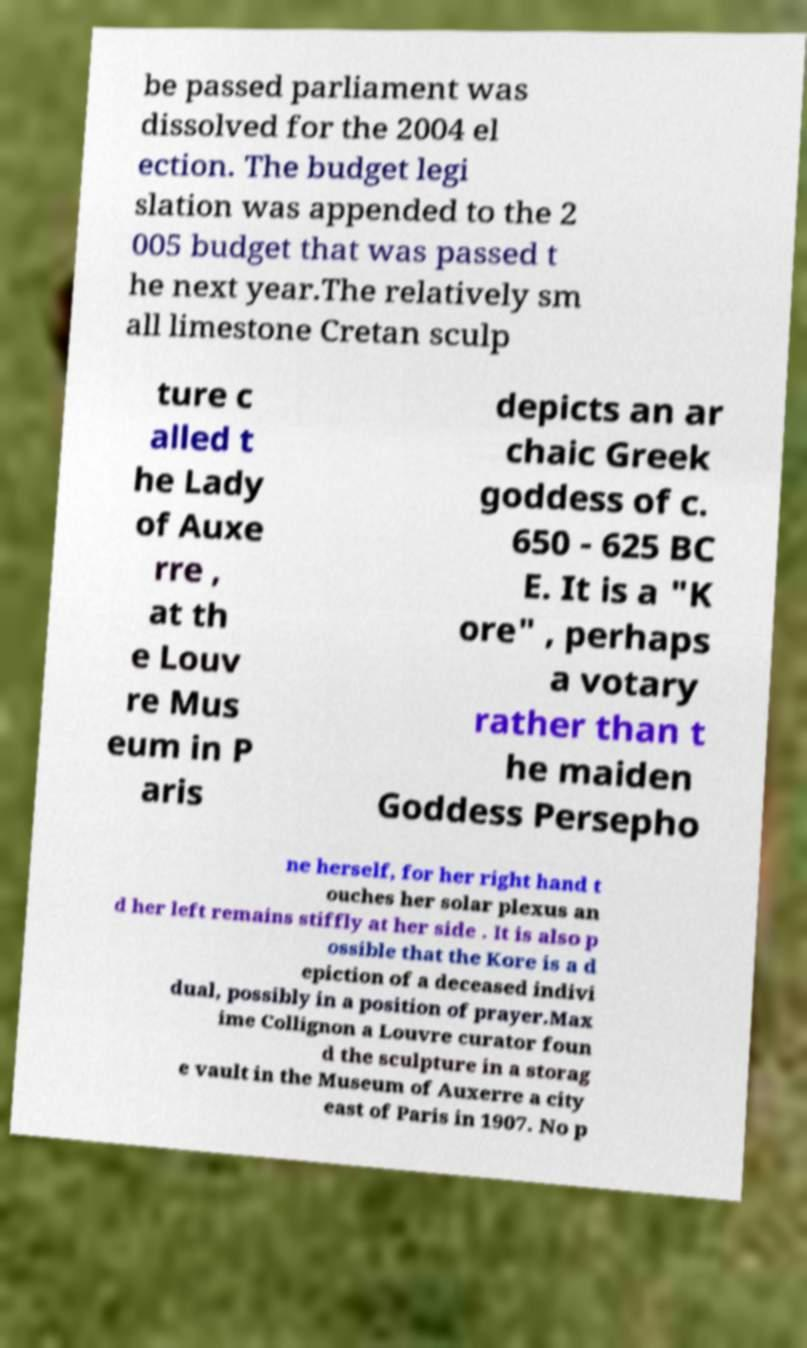Please read and relay the text visible in this image. What does it say? be passed parliament was dissolved for the 2004 el ection. The budget legi slation was appended to the 2 005 budget that was passed t he next year.The relatively sm all limestone Cretan sculp ture c alled t he Lady of Auxe rre , at th e Louv re Mus eum in P aris depicts an ar chaic Greek goddess of c. 650 - 625 BC E. It is a "K ore" , perhaps a votary rather than t he maiden Goddess Persepho ne herself, for her right hand t ouches her solar plexus an d her left remains stiffly at her side . It is also p ossible that the Kore is a d epiction of a deceased indivi dual, possibly in a position of prayer.Max ime Collignon a Louvre curator foun d the sculpture in a storag e vault in the Museum of Auxerre a city east of Paris in 1907. No p 